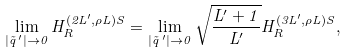<formula> <loc_0><loc_0><loc_500><loc_500>\lim _ { | \vec { q } \, ^ { \prime } | \to 0 } H ^ { ( 2 L ^ { \prime } , \rho L ) S } _ { R } = \lim _ { | \vec { q } \, ^ { \prime } | \to 0 } \sqrt { \frac { L ^ { \prime } + 1 } { L ^ { \prime } } } H ^ { ( 3 L ^ { \prime } , \rho L ) S } _ { R } ,</formula> 